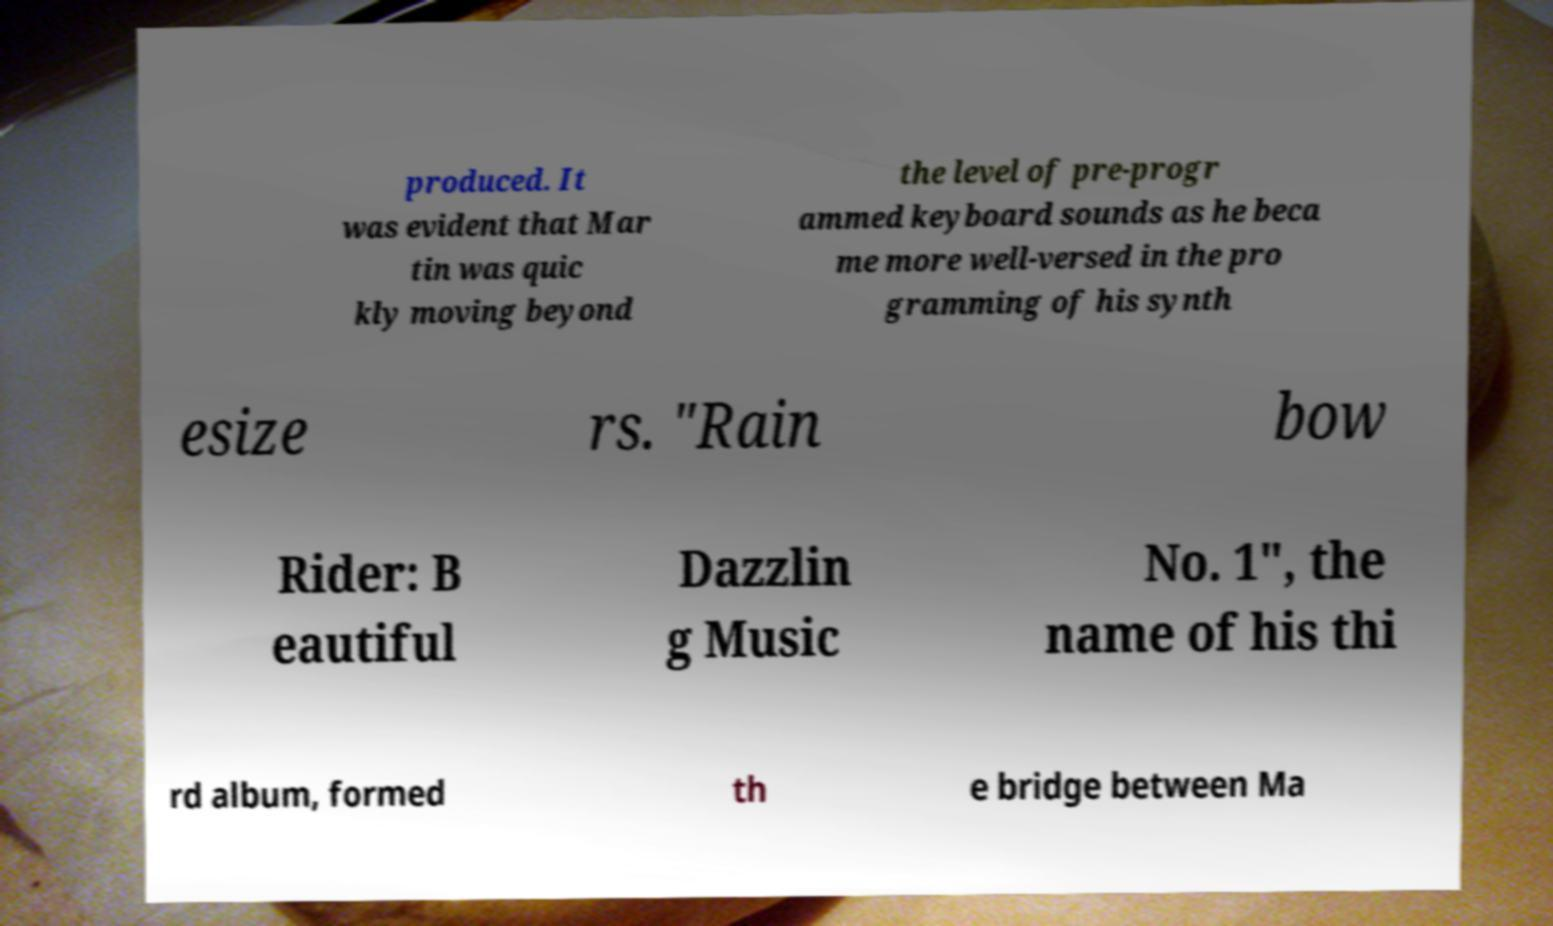I need the written content from this picture converted into text. Can you do that? produced. It was evident that Mar tin was quic kly moving beyond the level of pre-progr ammed keyboard sounds as he beca me more well-versed in the pro gramming of his synth esize rs. "Rain bow Rider: B eautiful Dazzlin g Music No. 1", the name of his thi rd album, formed th e bridge between Ma 